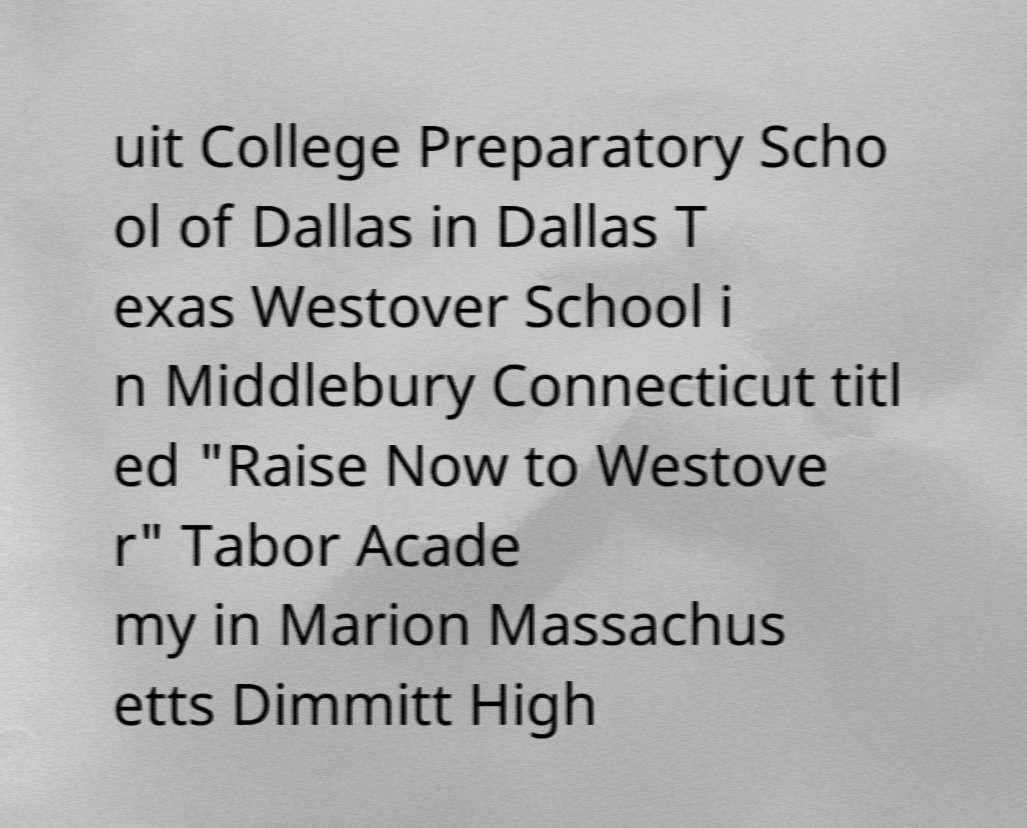There's text embedded in this image that I need extracted. Can you transcribe it verbatim? uit College Preparatory Scho ol of Dallas in Dallas T exas Westover School i n Middlebury Connecticut titl ed "Raise Now to Westove r" Tabor Acade my in Marion Massachus etts Dimmitt High 